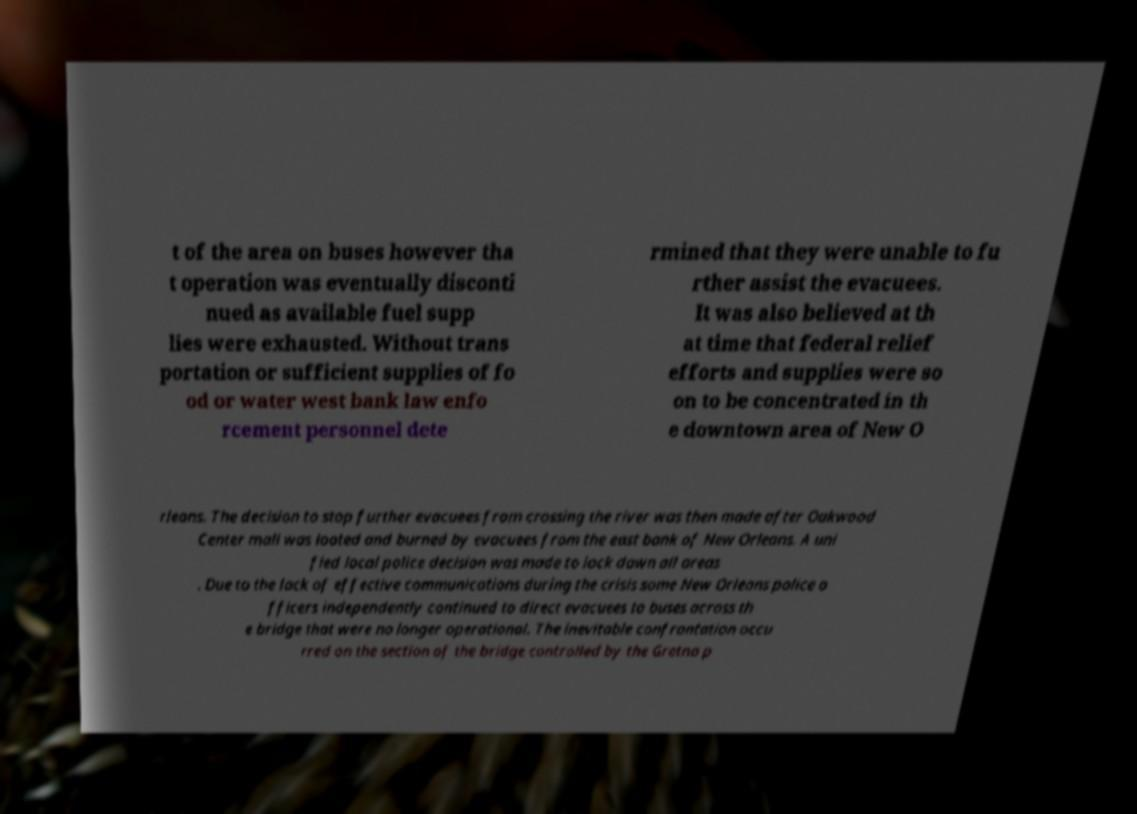Please read and relay the text visible in this image. What does it say? t of the area on buses however tha t operation was eventually disconti nued as available fuel supp lies were exhausted. Without trans portation or sufficient supplies of fo od or water west bank law enfo rcement personnel dete rmined that they were unable to fu rther assist the evacuees. It was also believed at th at time that federal relief efforts and supplies were so on to be concentrated in th e downtown area of New O rleans. The decision to stop further evacuees from crossing the river was then made after Oakwood Center mall was looted and burned by evacuees from the east bank of New Orleans. A uni fied local police decision was made to lock down all areas . Due to the lack of effective communications during the crisis some New Orleans police o fficers independently continued to direct evacuees to buses across th e bridge that were no longer operational. The inevitable confrontation occu rred on the section of the bridge controlled by the Gretna p 